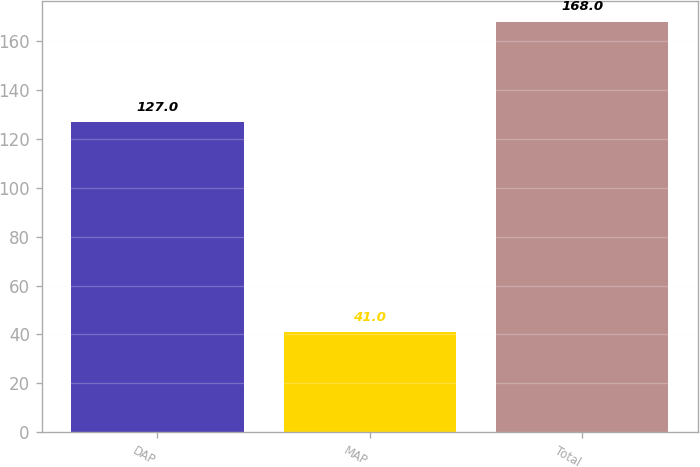Convert chart. <chart><loc_0><loc_0><loc_500><loc_500><bar_chart><fcel>DAP<fcel>MAP<fcel>Total<nl><fcel>127<fcel>41<fcel>168<nl></chart> 